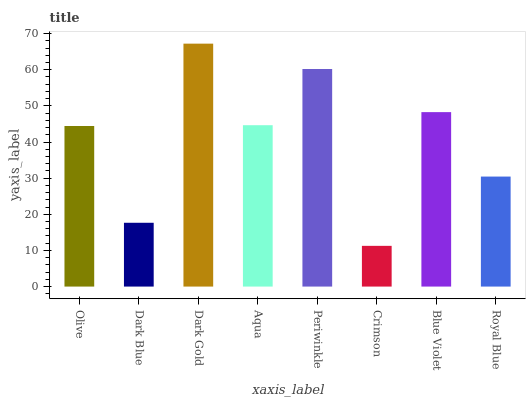Is Crimson the minimum?
Answer yes or no. Yes. Is Dark Gold the maximum?
Answer yes or no. Yes. Is Dark Blue the minimum?
Answer yes or no. No. Is Dark Blue the maximum?
Answer yes or no. No. Is Olive greater than Dark Blue?
Answer yes or no. Yes. Is Dark Blue less than Olive?
Answer yes or no. Yes. Is Dark Blue greater than Olive?
Answer yes or no. No. Is Olive less than Dark Blue?
Answer yes or no. No. Is Aqua the high median?
Answer yes or no. Yes. Is Olive the low median?
Answer yes or no. Yes. Is Dark Blue the high median?
Answer yes or no. No. Is Dark Blue the low median?
Answer yes or no. No. 